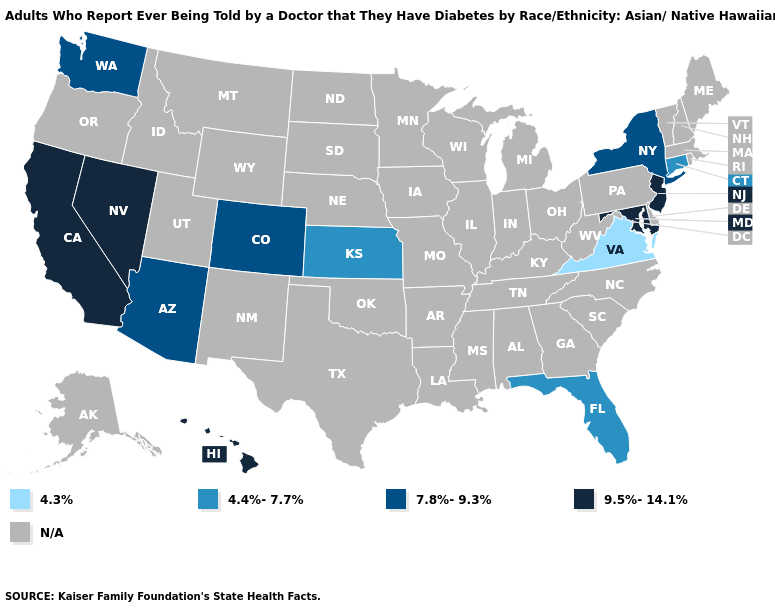Which states have the highest value in the USA?
Write a very short answer. California, Hawaii, Maryland, Nevada, New Jersey. Among the states that border Connecticut , which have the lowest value?
Keep it brief. New York. How many symbols are there in the legend?
Be succinct. 5. Is the legend a continuous bar?
Concise answer only. No. Among the states that border Oregon , which have the highest value?
Give a very brief answer. California, Nevada. Does the map have missing data?
Concise answer only. Yes. What is the value of Nevada?
Be succinct. 9.5%-14.1%. What is the value of Wisconsin?
Answer briefly. N/A. Name the states that have a value in the range 4.3%?
Concise answer only. Virginia. Which states have the lowest value in the USA?
Short answer required. Virginia. What is the value of Montana?
Quick response, please. N/A. What is the value of Wyoming?
Give a very brief answer. N/A. Name the states that have a value in the range 9.5%-14.1%?
Write a very short answer. California, Hawaii, Maryland, Nevada, New Jersey. 